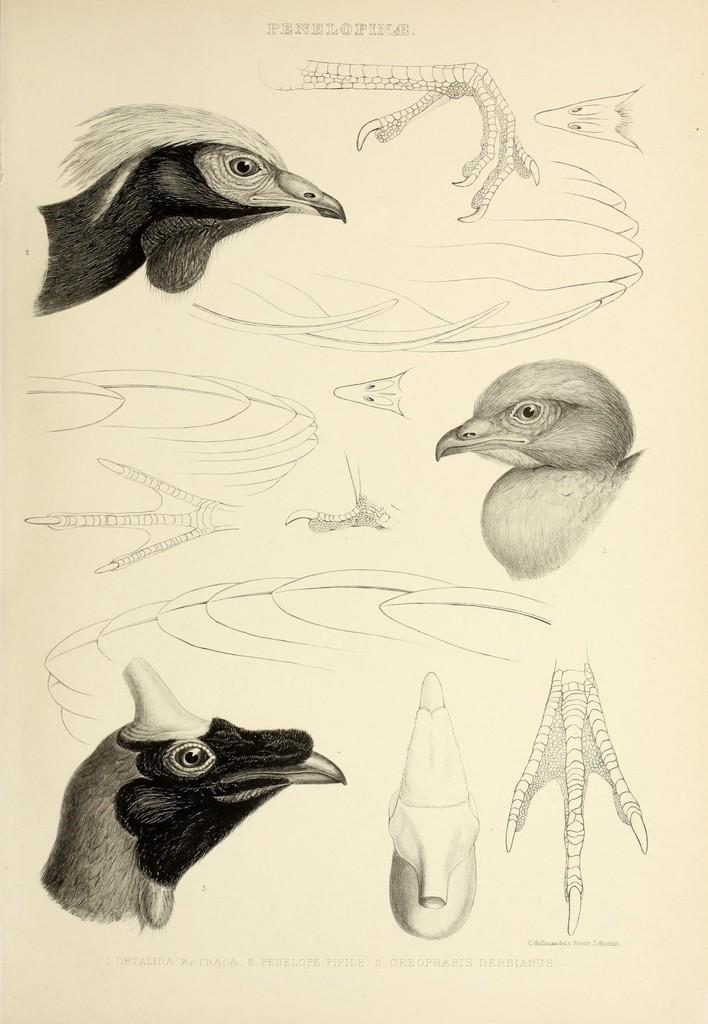What is present in the image that has both drawings and words? There is a paper in the image that has drawings and words on it. Can you describe the drawings on the paper? Unfortunately, the specific details of the drawings cannot be determined from the provided facts. What type of content is included in the words on the paper? The specific content of the words cannot be determined from the provided facts. How many ducks are present in the image? There are no ducks present in the image. What type of pencil is being used to draw on the paper? The provided facts do not mention the use of a pencil or any other drawing tool. 